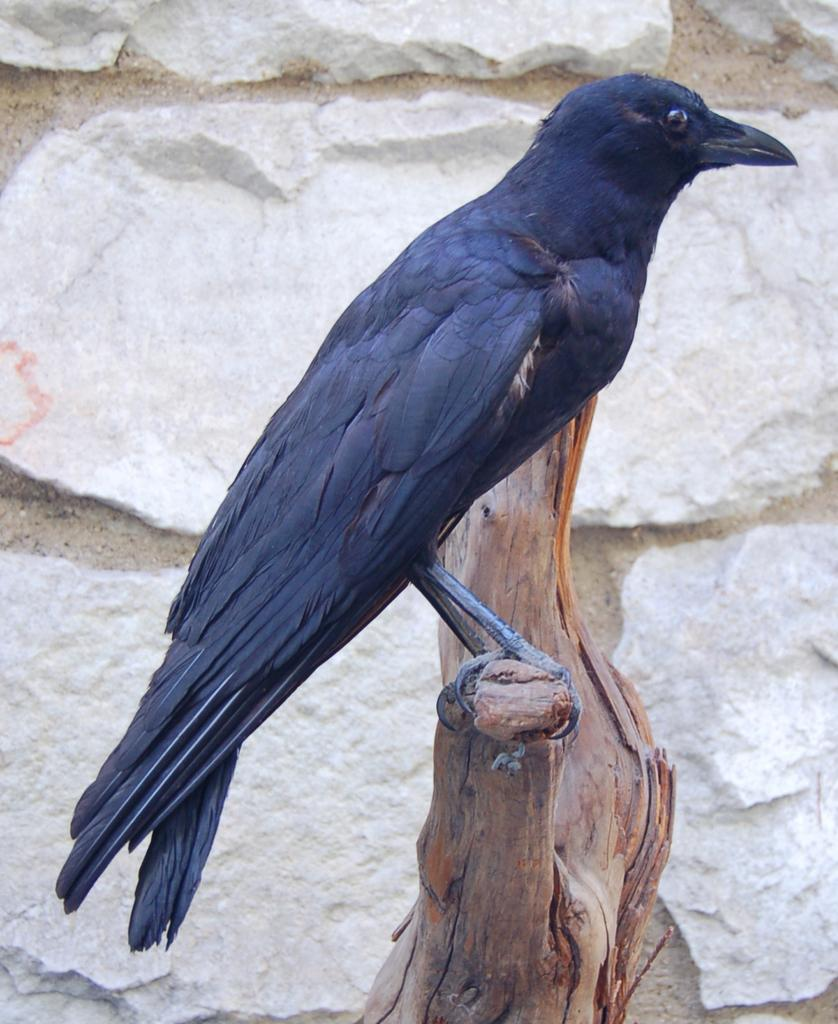What is the surface on which the image is placed? The image is on a wood surface. What animal is depicted in the image? There is a crow in the image. What can be seen in the background of the image? There is a stone wall in the background of the image. What type of ghost is visible in the image? There is no ghost present in the image; it features a crow and a stone wall in the background. 